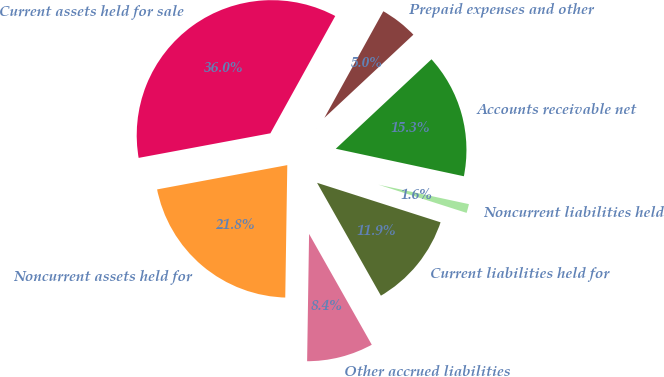<chart> <loc_0><loc_0><loc_500><loc_500><pie_chart><fcel>Accounts receivable net<fcel>Prepaid expenses and other<fcel>Current assets held for sale<fcel>Noncurrent assets held for<fcel>Other accrued liabilities<fcel>Current liabilities held for<fcel>Noncurrent liabilities held<nl><fcel>15.33%<fcel>5.0%<fcel>35.98%<fcel>21.82%<fcel>8.44%<fcel>11.88%<fcel>1.56%<nl></chart> 